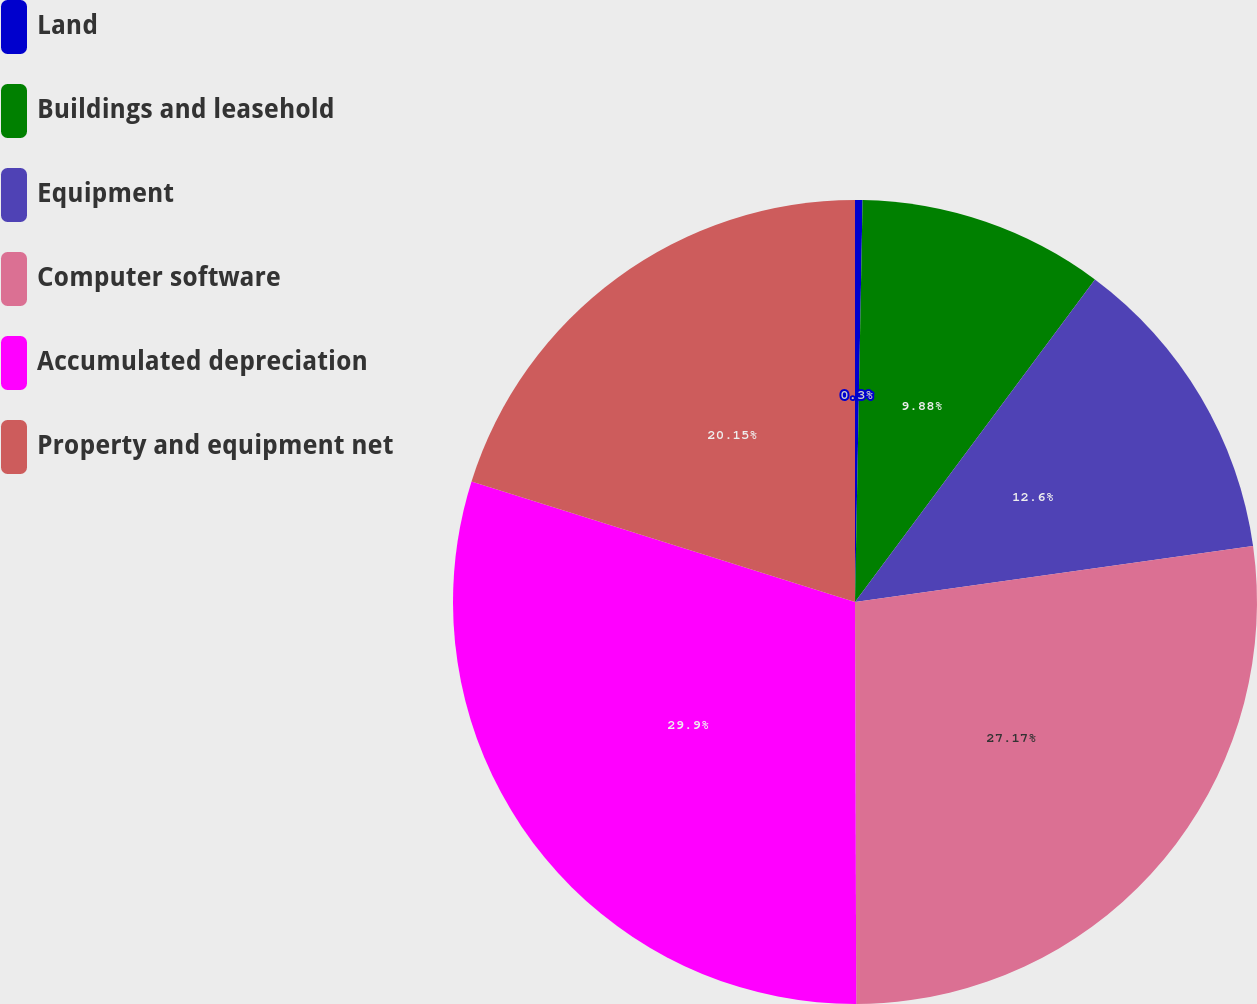Convert chart to OTSL. <chart><loc_0><loc_0><loc_500><loc_500><pie_chart><fcel>Land<fcel>Buildings and leasehold<fcel>Equipment<fcel>Computer software<fcel>Accumulated depreciation<fcel>Property and equipment net<nl><fcel>0.3%<fcel>9.88%<fcel>12.6%<fcel>27.17%<fcel>29.9%<fcel>20.15%<nl></chart> 